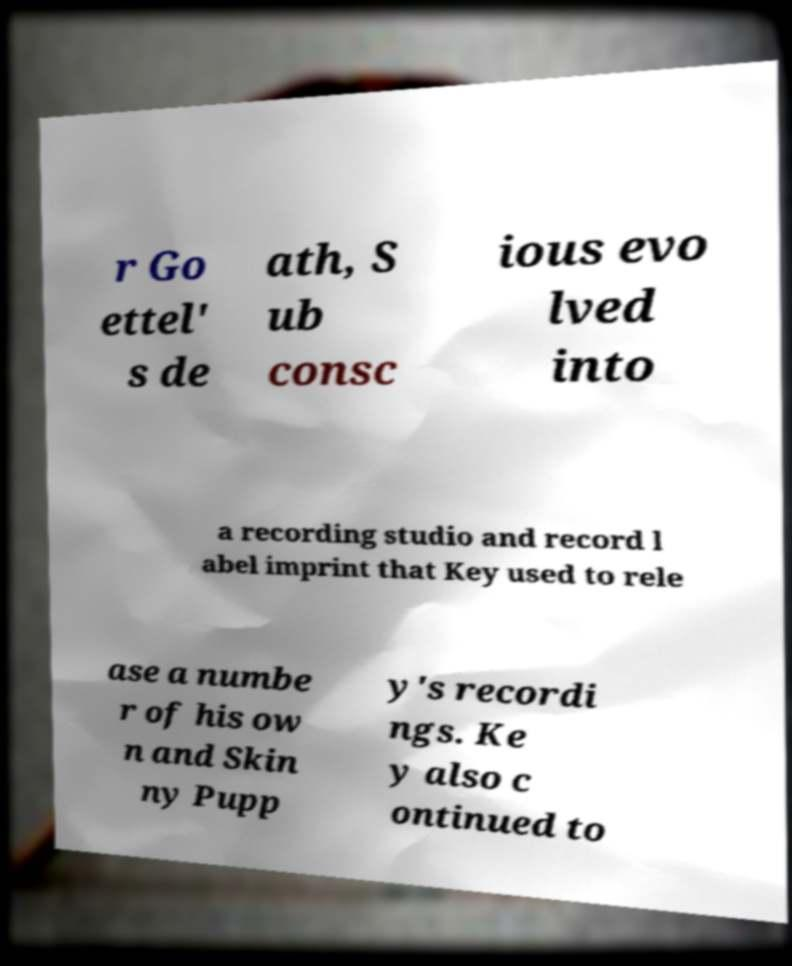Can you accurately transcribe the text from the provided image for me? r Go ettel' s de ath, S ub consc ious evo lved into a recording studio and record l abel imprint that Key used to rele ase a numbe r of his ow n and Skin ny Pupp y's recordi ngs. Ke y also c ontinued to 